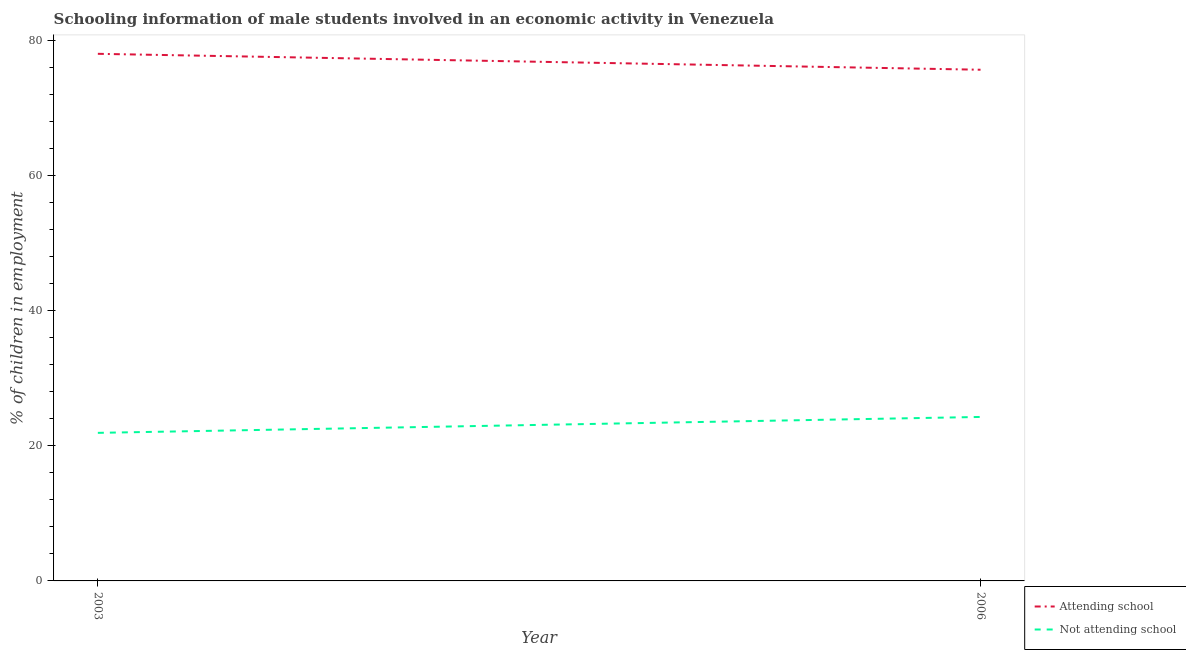How many different coloured lines are there?
Your answer should be very brief. 2. Does the line corresponding to percentage of employed males who are attending school intersect with the line corresponding to percentage of employed males who are not attending school?
Ensure brevity in your answer.  No. Is the number of lines equal to the number of legend labels?
Provide a short and direct response. Yes. What is the percentage of employed males who are attending school in 2003?
Provide a short and direct response. 78.07. Across all years, what is the maximum percentage of employed males who are attending school?
Provide a succinct answer. 78.07. Across all years, what is the minimum percentage of employed males who are attending school?
Offer a terse response. 75.71. What is the total percentage of employed males who are not attending school in the graph?
Your response must be concise. 46.22. What is the difference between the percentage of employed males who are attending school in 2003 and that in 2006?
Ensure brevity in your answer.  2.36. What is the difference between the percentage of employed males who are not attending school in 2006 and the percentage of employed males who are attending school in 2003?
Your answer should be very brief. -53.78. What is the average percentage of employed males who are attending school per year?
Your answer should be very brief. 76.89. In the year 2003, what is the difference between the percentage of employed males who are not attending school and percentage of employed males who are attending school?
Offer a very short reply. -56.14. What is the ratio of the percentage of employed males who are not attending school in 2003 to that in 2006?
Your response must be concise. 0.9. How many years are there in the graph?
Ensure brevity in your answer.  2. What is the difference between two consecutive major ticks on the Y-axis?
Provide a succinct answer. 20. Are the values on the major ticks of Y-axis written in scientific E-notation?
Your answer should be compact. No. Does the graph contain any zero values?
Keep it short and to the point. No. How many legend labels are there?
Provide a short and direct response. 2. What is the title of the graph?
Keep it short and to the point. Schooling information of male students involved in an economic activity in Venezuela. Does "Under five" appear as one of the legend labels in the graph?
Offer a very short reply. No. What is the label or title of the X-axis?
Provide a short and direct response. Year. What is the label or title of the Y-axis?
Your answer should be very brief. % of children in employment. What is the % of children in employment in Attending school in 2003?
Your response must be concise. 78.07. What is the % of children in employment of Not attending school in 2003?
Offer a very short reply. 21.93. What is the % of children in employment of Attending school in 2006?
Your answer should be very brief. 75.71. What is the % of children in employment of Not attending school in 2006?
Provide a short and direct response. 24.29. Across all years, what is the maximum % of children in employment in Attending school?
Offer a very short reply. 78.07. Across all years, what is the maximum % of children in employment in Not attending school?
Provide a short and direct response. 24.29. Across all years, what is the minimum % of children in employment of Attending school?
Make the answer very short. 75.71. Across all years, what is the minimum % of children in employment in Not attending school?
Your response must be concise. 21.93. What is the total % of children in employment of Attending school in the graph?
Ensure brevity in your answer.  153.78. What is the total % of children in employment in Not attending school in the graph?
Provide a succinct answer. 46.22. What is the difference between the % of children in employment in Attending school in 2003 and that in 2006?
Make the answer very short. 2.36. What is the difference between the % of children in employment of Not attending school in 2003 and that in 2006?
Offer a terse response. -2.36. What is the difference between the % of children in employment in Attending school in 2003 and the % of children in employment in Not attending school in 2006?
Give a very brief answer. 53.78. What is the average % of children in employment of Attending school per year?
Give a very brief answer. 76.89. What is the average % of children in employment in Not attending school per year?
Your response must be concise. 23.11. In the year 2003, what is the difference between the % of children in employment in Attending school and % of children in employment in Not attending school?
Offer a very short reply. 56.14. In the year 2006, what is the difference between the % of children in employment of Attending school and % of children in employment of Not attending school?
Provide a succinct answer. 51.43. What is the ratio of the % of children in employment of Attending school in 2003 to that in 2006?
Make the answer very short. 1.03. What is the ratio of the % of children in employment in Not attending school in 2003 to that in 2006?
Provide a succinct answer. 0.9. What is the difference between the highest and the second highest % of children in employment of Attending school?
Give a very brief answer. 2.36. What is the difference between the highest and the second highest % of children in employment in Not attending school?
Provide a short and direct response. 2.36. What is the difference between the highest and the lowest % of children in employment of Attending school?
Provide a succinct answer. 2.36. What is the difference between the highest and the lowest % of children in employment in Not attending school?
Provide a short and direct response. 2.36. 